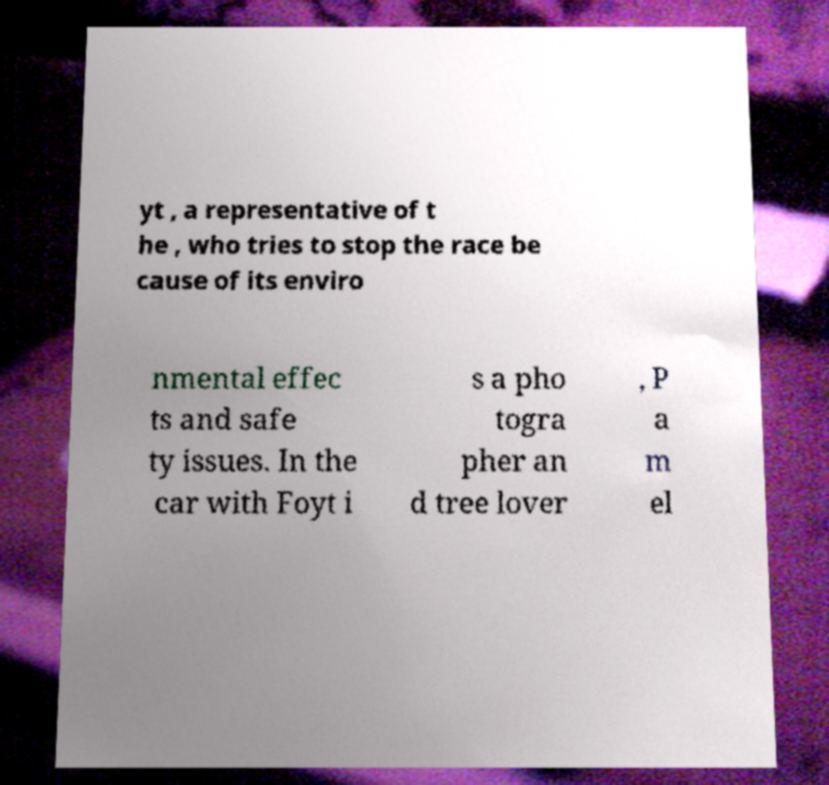Could you extract and type out the text from this image? yt , a representative of t he , who tries to stop the race be cause of its enviro nmental effec ts and safe ty issues. In the car with Foyt i s a pho togra pher an d tree lover , P a m el 